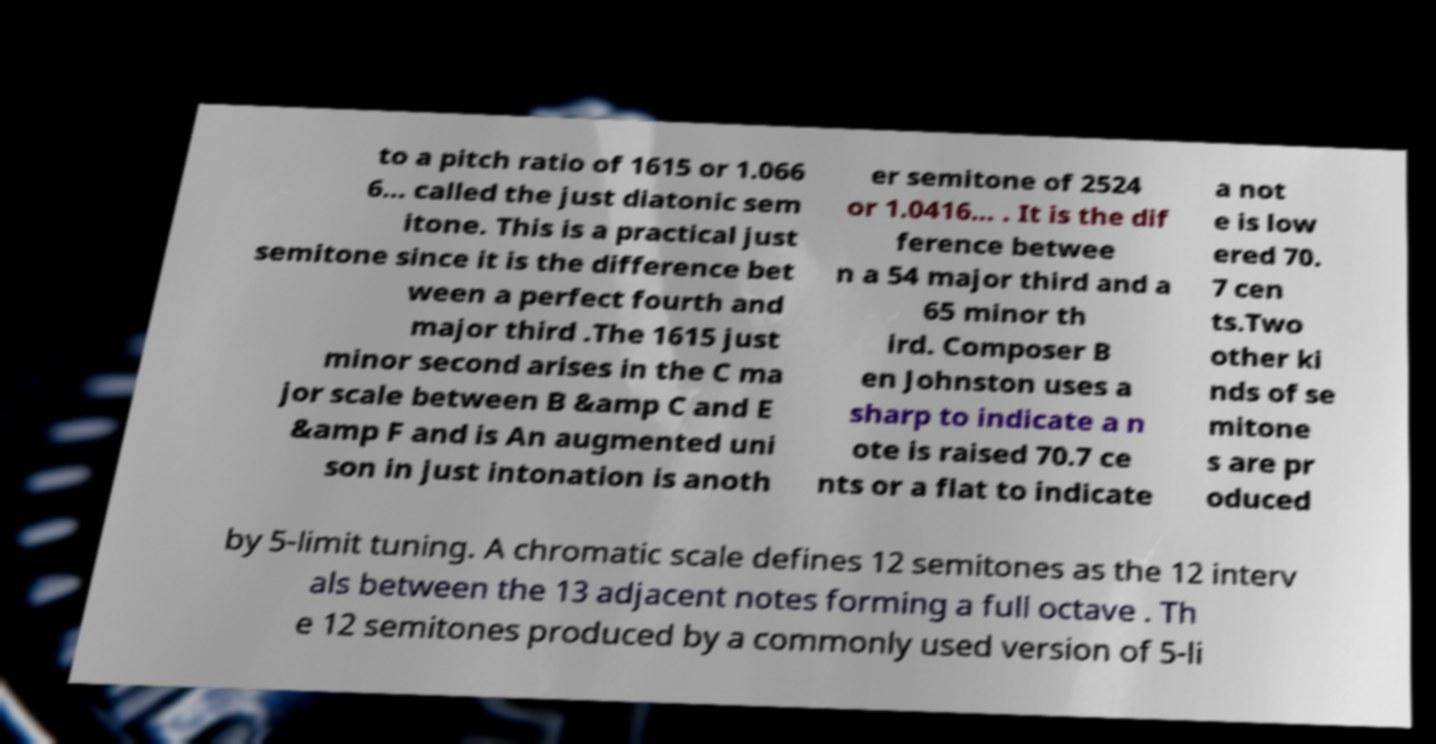Can you read and provide the text displayed in the image?This photo seems to have some interesting text. Can you extract and type it out for me? to a pitch ratio of 1615 or 1.066 6... called the just diatonic sem itone. This is a practical just semitone since it is the difference bet ween a perfect fourth and major third .The 1615 just minor second arises in the C ma jor scale between B &amp C and E &amp F and is An augmented uni son in just intonation is anoth er semitone of 2524 or 1.0416... . It is the dif ference betwee n a 54 major third and a 65 minor th ird. Composer B en Johnston uses a sharp to indicate a n ote is raised 70.7 ce nts or a flat to indicate a not e is low ered 70. 7 cen ts.Two other ki nds of se mitone s are pr oduced by 5-limit tuning. A chromatic scale defines 12 semitones as the 12 interv als between the 13 adjacent notes forming a full octave . Th e 12 semitones produced by a commonly used version of 5-li 